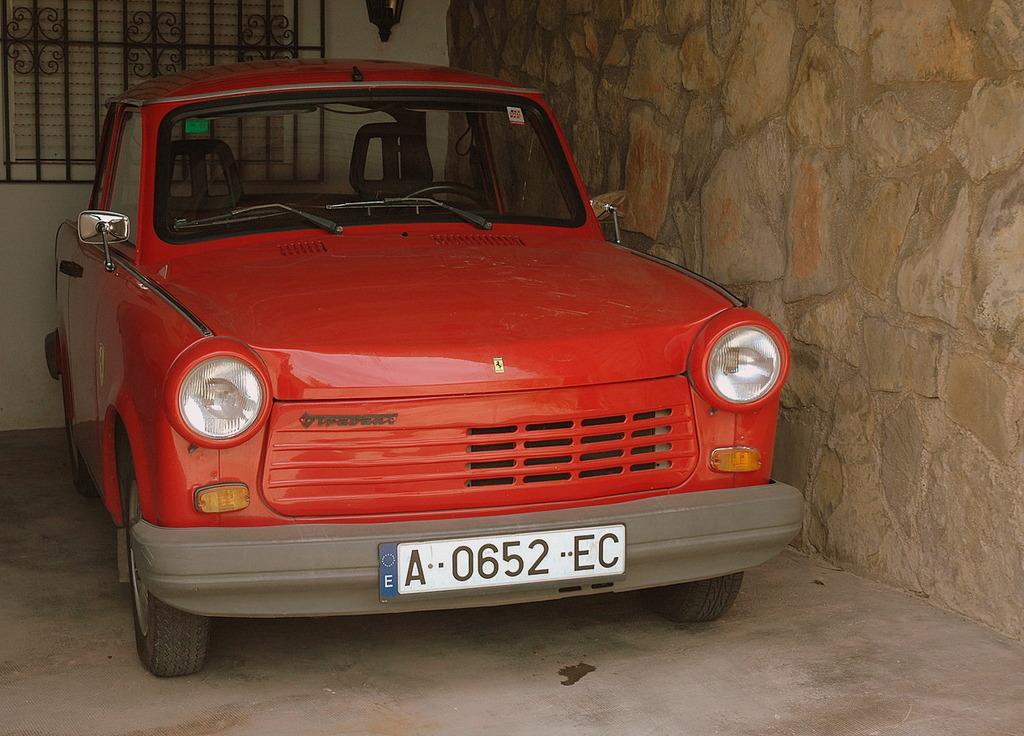How would you summarize this image in a sentence or two? In this image we can see a car which is placed on the surface. We can also see a street lamp and a metal grill on a wall. 